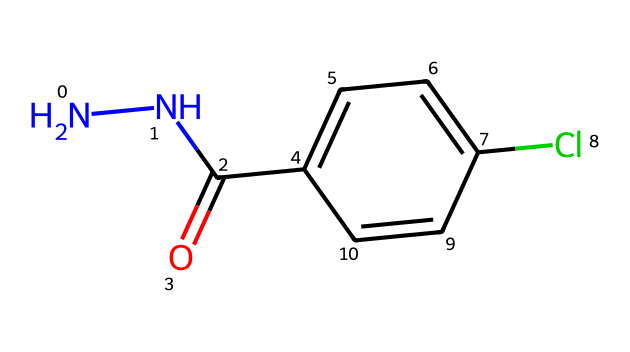What is the functional group present in this compound? The chemical structure contains a carbonyl group (C=O) indicated by the formula C(=O) next to the nitrogen-nitrogen (N-N) bond, which is characteristic of amides.
Answer: carbonyl group How many chlorine atoms are present in the structure? The SMILES notation has one 'Cl' indicating there is one chlorine atom attached to the benzene ring portion (c1ccc(Cl)cc1).
Answer: one What type of molecule is represented by this structure? The presence of the N-N bond along with a carbonyl and a phenyl group indicates that this compound is a hydrazine derivative with structural features of an amide.
Answer: hydrazine derivative How many nitrogen atoms are in the entire compound? The structure contains two nitrogen atoms as represented by 'N' in the SMILES notation at the beginning, and it is a characteristic feature of hydrazines.
Answer: two Is this compound likely to be polar or nonpolar? The presence of functional groups such as the carbonyl and the amino group (part of the hydrazine structure) increases polarity due to their ability to form hydrogen bonds and interactions with polar solvents.
Answer: polar What is the molecular weight of this compound? By analyzing the elemental composition from the SMILES, you can determine the molecular weights of individual atoms (N=14, C=12, O=16, Cl=35.5) and calculate the total molecular weight around 180.5 g/mol.
Answer: approximately 180.5 g/mol 